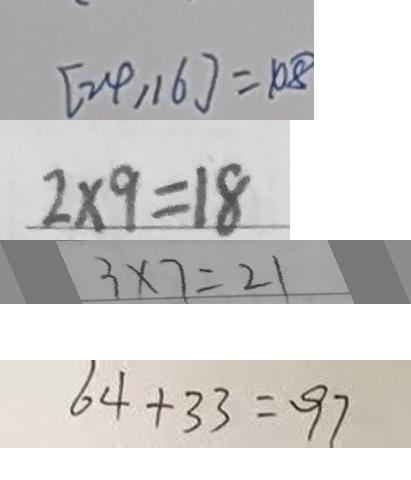Convert formula to latex. <formula><loc_0><loc_0><loc_500><loc_500>[ 2 4 , 1 6 ] = 1 0 8 
 2 \times 9 = 1 8 
 3 \times 7 = 2 1 
 6 4 + 3 3 = 9 7</formula> 